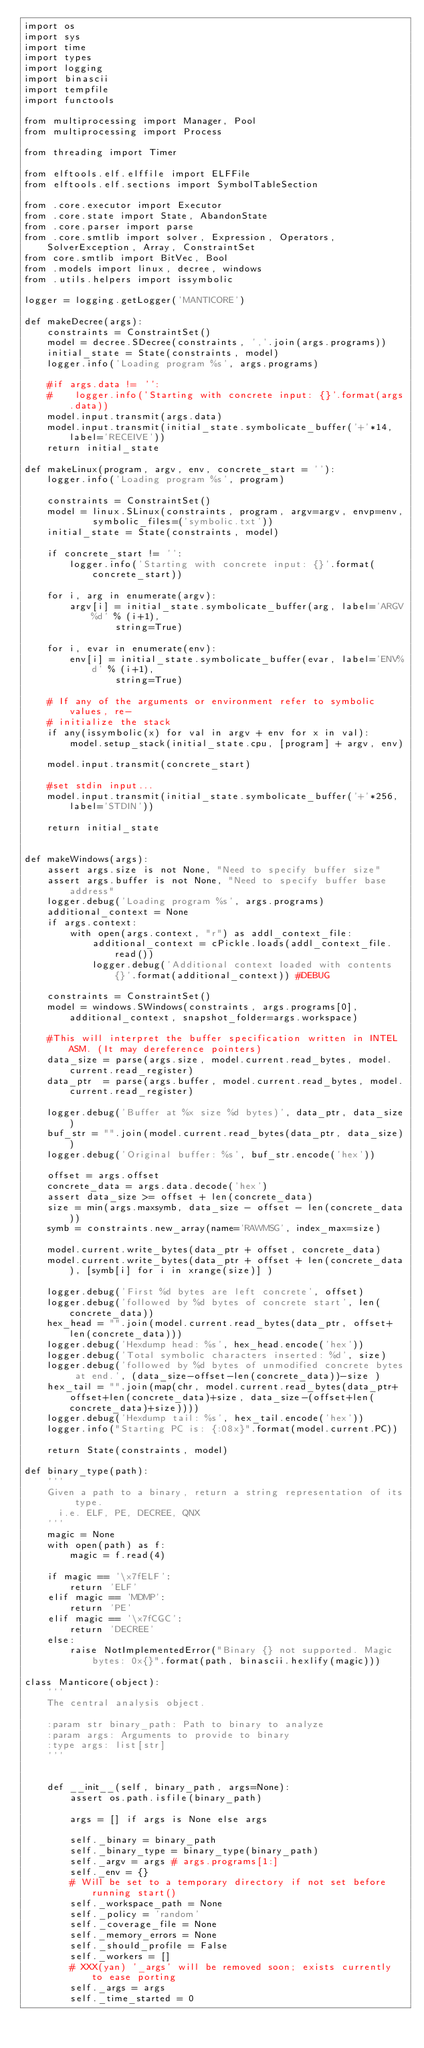Convert code to text. <code><loc_0><loc_0><loc_500><loc_500><_Python_>import os
import sys
import time
import types
import logging
import binascii
import tempfile
import functools

from multiprocessing import Manager, Pool
from multiprocessing import Process

from threading import Timer

from elftools.elf.elffile import ELFFile
from elftools.elf.sections import SymbolTableSection

from .core.executor import Executor
from .core.state import State, AbandonState
from .core.parser import parse
from .core.smtlib import solver, Expression, Operators, SolverException, Array, ConstraintSet
from core.smtlib import BitVec, Bool
from .models import linux, decree, windows
from .utils.helpers import issymbolic

logger = logging.getLogger('MANTICORE')

def makeDecree(args):
    constraints = ConstraintSet()
    model = decree.SDecree(constraints, ','.join(args.programs))
    initial_state = State(constraints, model)
    logger.info('Loading program %s', args.programs)

    #if args.data != '':
    #    logger.info('Starting with concrete input: {}'.format(args.data))
    model.input.transmit(args.data)
    model.input.transmit(initial_state.symbolicate_buffer('+'*14, label='RECEIVE'))
    return initial_state

def makeLinux(program, argv, env, concrete_start = ''):
    logger.info('Loading program %s', program)

    constraints = ConstraintSet()
    model = linux.SLinux(constraints, program, argv=argv, envp=env,
            symbolic_files=('symbolic.txt'))
    initial_state = State(constraints, model)

    if concrete_start != '':
        logger.info('Starting with concrete input: {}'.format(concrete_start))

    for i, arg in enumerate(argv):
        argv[i] = initial_state.symbolicate_buffer(arg, label='ARGV%d' % (i+1),
                string=True)

    for i, evar in enumerate(env):
        env[i] = initial_state.symbolicate_buffer(evar, label='ENV%d' % (i+1),
                string=True)

    # If any of the arguments or environment refer to symbolic values, re-
    # initialize the stack
    if any(issymbolic(x) for val in argv + env for x in val):
        model.setup_stack(initial_state.cpu, [program] + argv, env)

    model.input.transmit(concrete_start)

    #set stdin input...
    model.input.transmit(initial_state.symbolicate_buffer('+'*256, label='STDIN'))

    return initial_state 


def makeWindows(args):
    assert args.size is not None, "Need to specify buffer size"
    assert args.buffer is not None, "Need to specify buffer base address"
    logger.debug('Loading program %s', args.programs)
    additional_context = None
    if args.context:
        with open(args.context, "r") as addl_context_file:
            additional_context = cPickle.loads(addl_context_file.read())
            logger.debug('Additional context loaded with contents {}'.format(additional_context)) #DEBUG

    constraints = ConstraintSet()
    model = windows.SWindows(constraints, args.programs[0], additional_context, snapshot_folder=args.workspace)

    #This will interpret the buffer specification written in INTEL ASM. (It may dereference pointers)
    data_size = parse(args.size, model.current.read_bytes, model.current.read_register)
    data_ptr  = parse(args.buffer, model.current.read_bytes, model.current.read_register)

    logger.debug('Buffer at %x size %d bytes)', data_ptr, data_size)
    buf_str = "".join(model.current.read_bytes(data_ptr, data_size))
    logger.debug('Original buffer: %s', buf_str.encode('hex'))

    offset = args.offset 
    concrete_data = args.data.decode('hex')
    assert data_size >= offset + len(concrete_data)
    size = min(args.maxsymb, data_size - offset - len(concrete_data))
    symb = constraints.new_array(name='RAWMSG', index_max=size)

    model.current.write_bytes(data_ptr + offset, concrete_data)
    model.current.write_bytes(data_ptr + offset + len(concrete_data), [symb[i] for i in xrange(size)] )

    logger.debug('First %d bytes are left concrete', offset)
    logger.debug('followed by %d bytes of concrete start', len(concrete_data))
    hex_head = "".join(model.current.read_bytes(data_ptr, offset+len(concrete_data)))
    logger.debug('Hexdump head: %s', hex_head.encode('hex'))
    logger.debug('Total symbolic characters inserted: %d', size)
    logger.debug('followed by %d bytes of unmodified concrete bytes at end.', (data_size-offset-len(concrete_data))-size )
    hex_tail = "".join(map(chr, model.current.read_bytes(data_ptr+offset+len(concrete_data)+size, data_size-(offset+len(concrete_data)+size))))
    logger.debug('Hexdump tail: %s', hex_tail.encode('hex'))
    logger.info("Starting PC is: {:08x}".format(model.current.PC))

    return State(constraints, model)

def binary_type(path):
    '''
    Given a path to a binary, return a string representation of its type.
      i.e. ELF, PE, DECREE, QNX
    '''
    magic = None
    with open(path) as f:
        magic = f.read(4)

    if magic == '\x7fELF':
        return 'ELF'
    elif magic == 'MDMP':
        return 'PE'
    elif magic == '\x7fCGC':
        return 'DECREE'
    else:
        raise NotImplementedError("Binary {} not supported. Magic bytes: 0x{}".format(path, binascii.hexlify(magic)))

class Manticore(object):
    '''
    The central analysis object.

    :param str binary_path: Path to binary to analyze
    :param args: Arguments to provide to binary
    :type args: list[str]
    '''


    def __init__(self, binary_path, args=None):
        assert os.path.isfile(binary_path)

        args = [] if args is None else args

        self._binary = binary_path
        self._binary_type = binary_type(binary_path)
        self._argv = args # args.programs[1:]
        self._env = {}
        # Will be set to a temporary directory if not set before running start()
        self._workspace_path = None
        self._policy = 'random'
        self._coverage_file = None
        self._memory_errors = None
        self._should_profile = False
        self._workers = []
        # XXX(yan) '_args' will be removed soon; exists currently to ease porting
        self._args = args
        self._time_started = 0</code> 